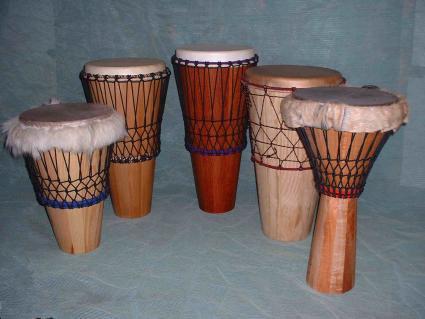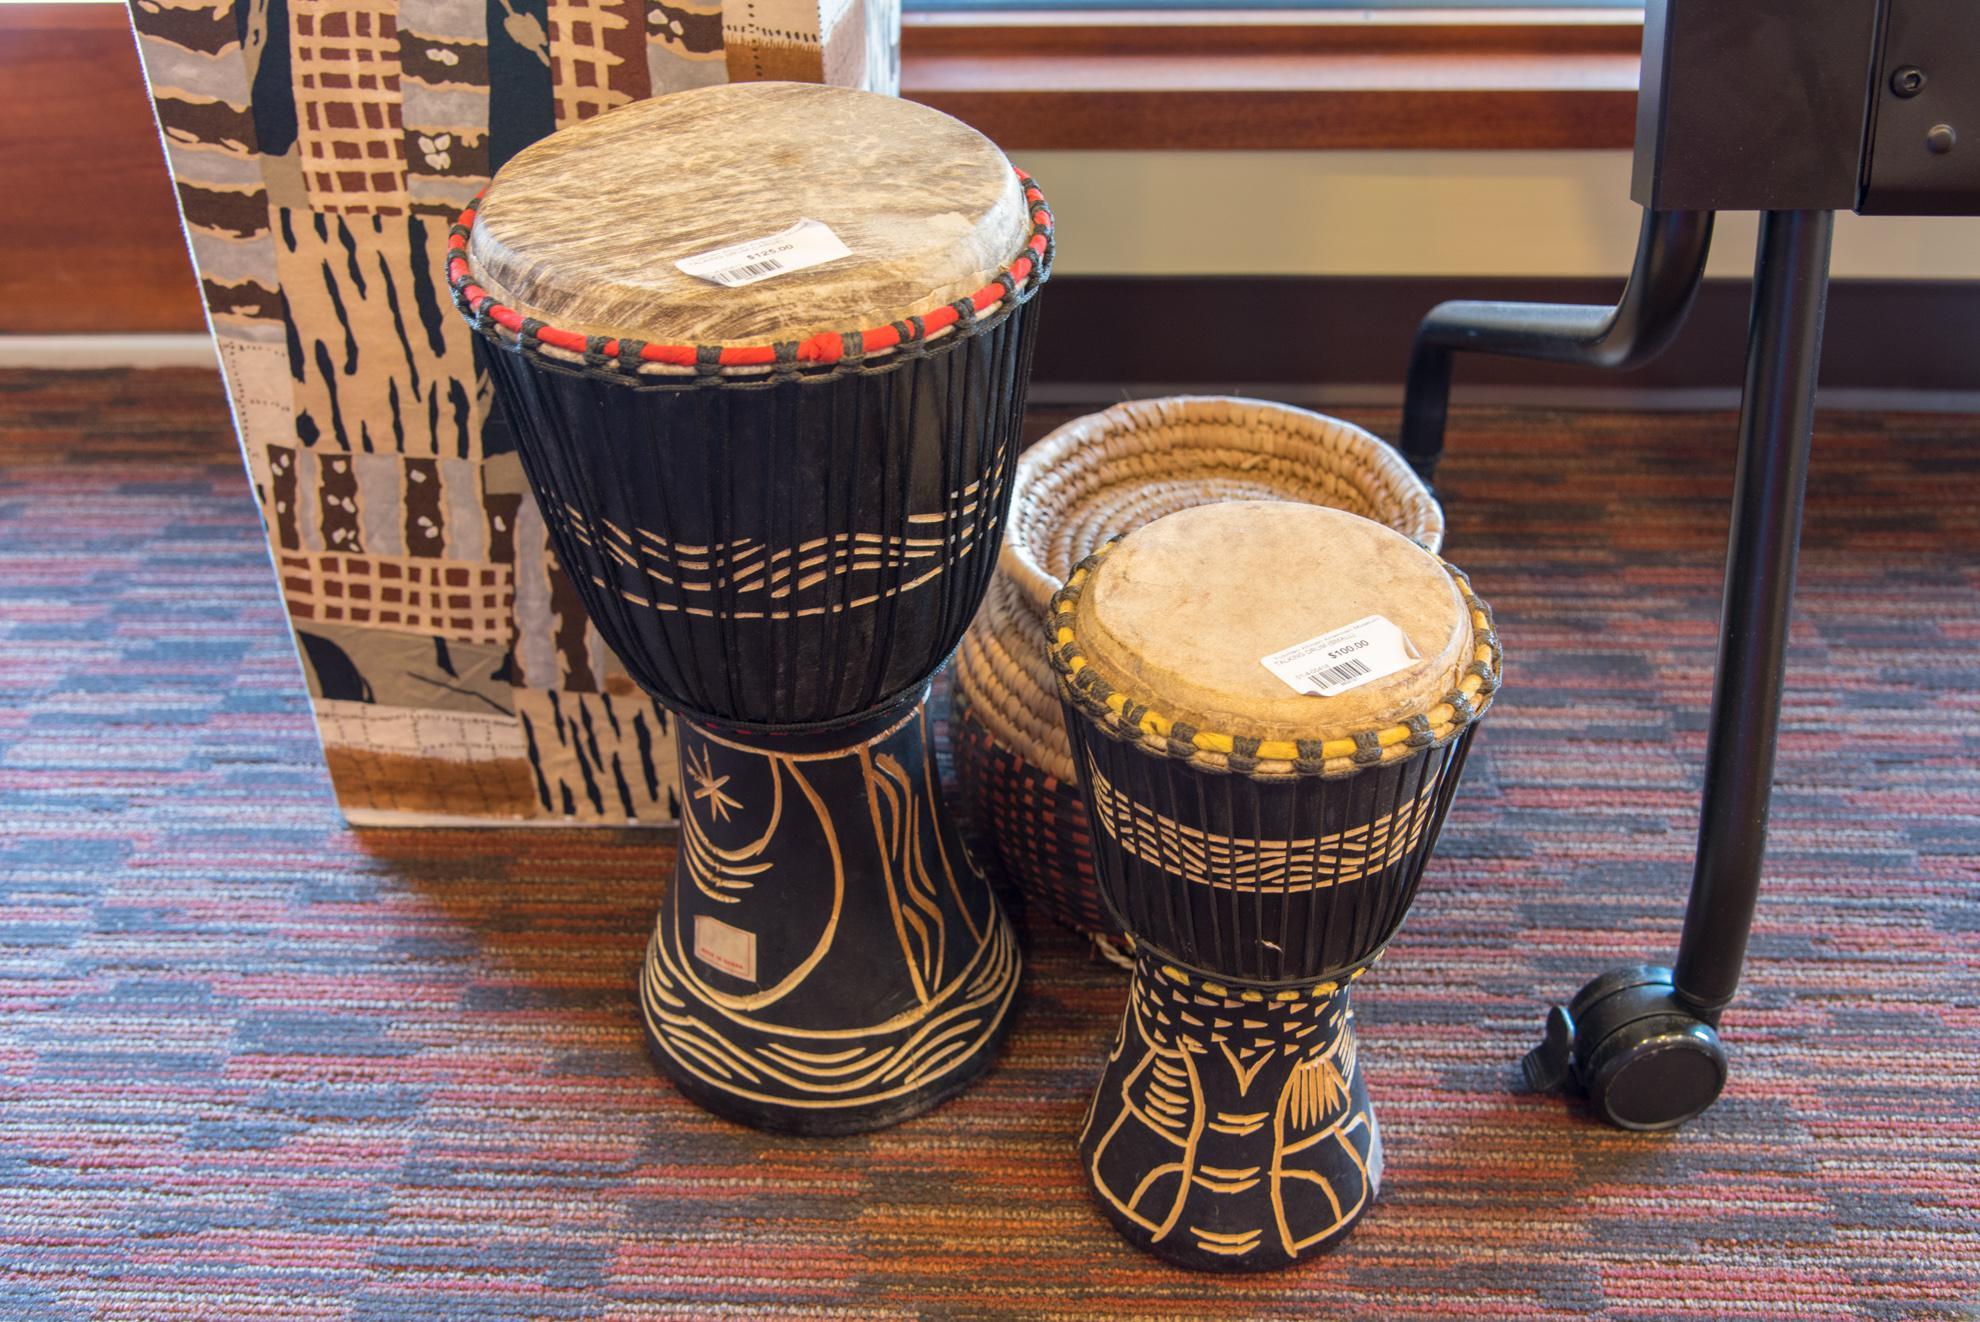The first image is the image on the left, the second image is the image on the right. For the images displayed, is the sentence "There are a total of four drums." factually correct? Answer yes or no. No. The first image is the image on the left, the second image is the image on the right. Considering the images on both sides, is "There are exactly two bongo drums." valid? Answer yes or no. No. 